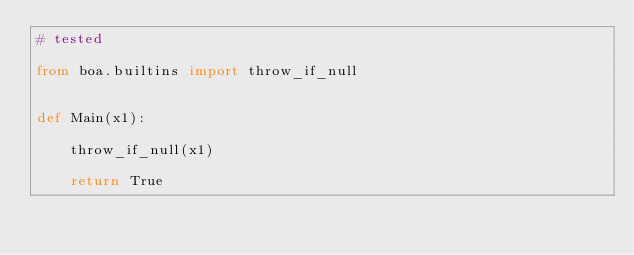Convert code to text. <code><loc_0><loc_0><loc_500><loc_500><_Python_># tested

from boa.builtins import throw_if_null


def Main(x1):

    throw_if_null(x1)

    return True
</code> 